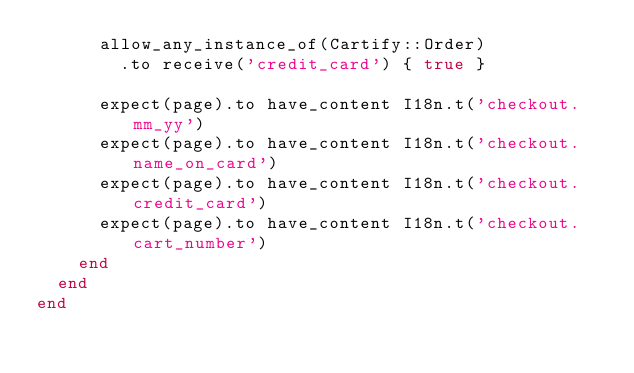Convert code to text. <code><loc_0><loc_0><loc_500><loc_500><_Ruby_>      allow_any_instance_of(Cartify::Order)
        .to receive('credit_card') { true }

      expect(page).to have_content I18n.t('checkout.mm_yy')
      expect(page).to have_content I18n.t('checkout.name_on_card')
      expect(page).to have_content I18n.t('checkout.credit_card')
      expect(page).to have_content I18n.t('checkout.cart_number')
    end
  end
end
</code> 